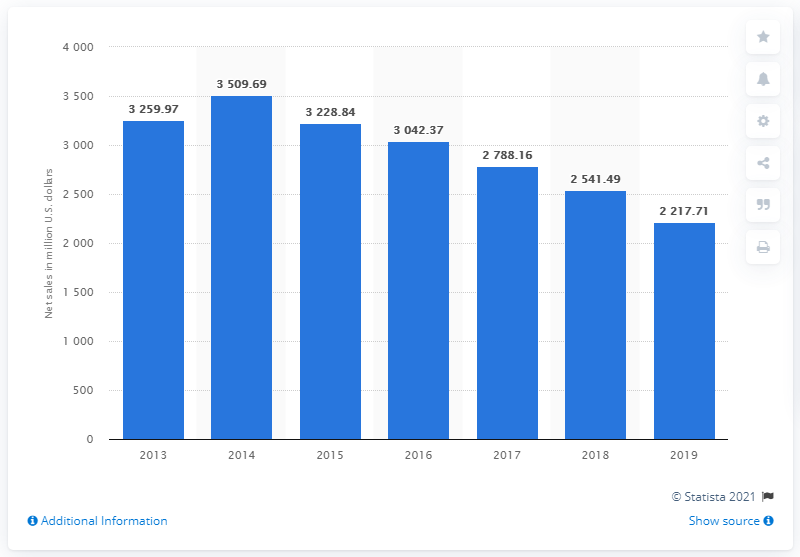List a handful of essential elements in this visual. In 2019, Fossil Group's net sales were $2217.71 million. 